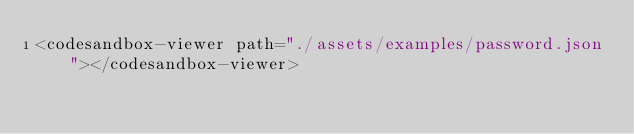<code> <loc_0><loc_0><loc_500><loc_500><_HTML_><codesandbox-viewer path="./assets/examples/password.json"></codesandbox-viewer></code> 